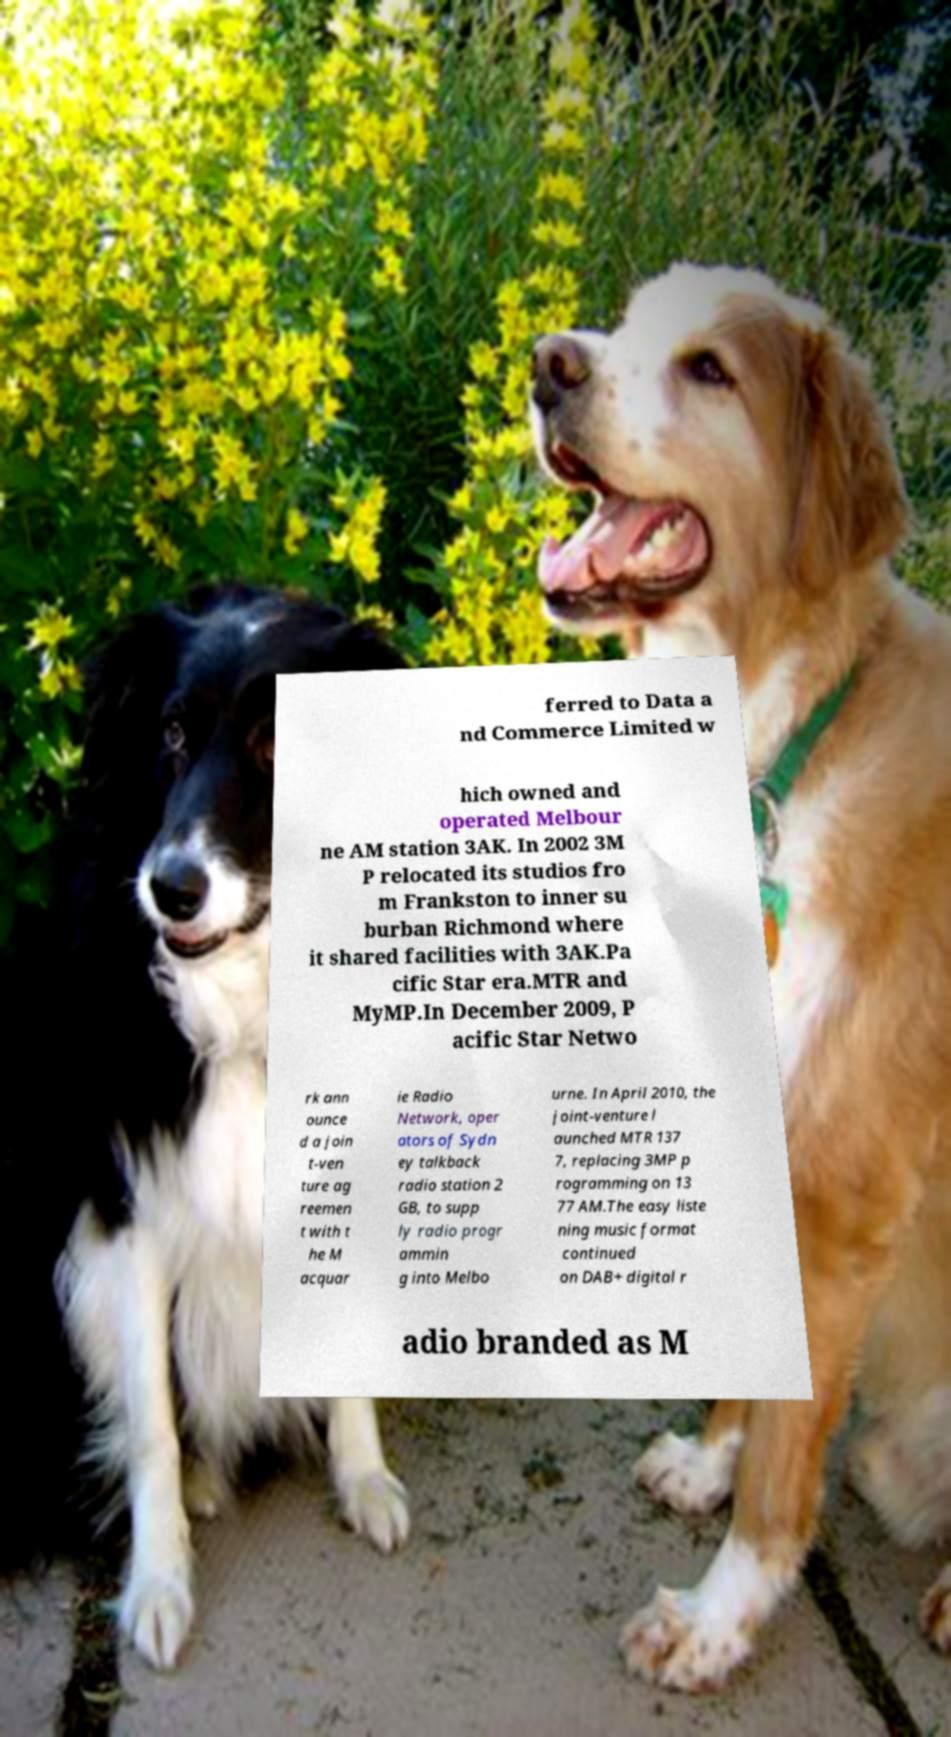For documentation purposes, I need the text within this image transcribed. Could you provide that? ferred to Data a nd Commerce Limited w hich owned and operated Melbour ne AM station 3AK. In 2002 3M P relocated its studios fro m Frankston to inner su burban Richmond where it shared facilities with 3AK.Pa cific Star era.MTR and MyMP.In December 2009, P acific Star Netwo rk ann ounce d a join t-ven ture ag reemen t with t he M acquar ie Radio Network, oper ators of Sydn ey talkback radio station 2 GB, to supp ly radio progr ammin g into Melbo urne. In April 2010, the joint-venture l aunched MTR 137 7, replacing 3MP p rogramming on 13 77 AM.The easy liste ning music format continued on DAB+ digital r adio branded as M 